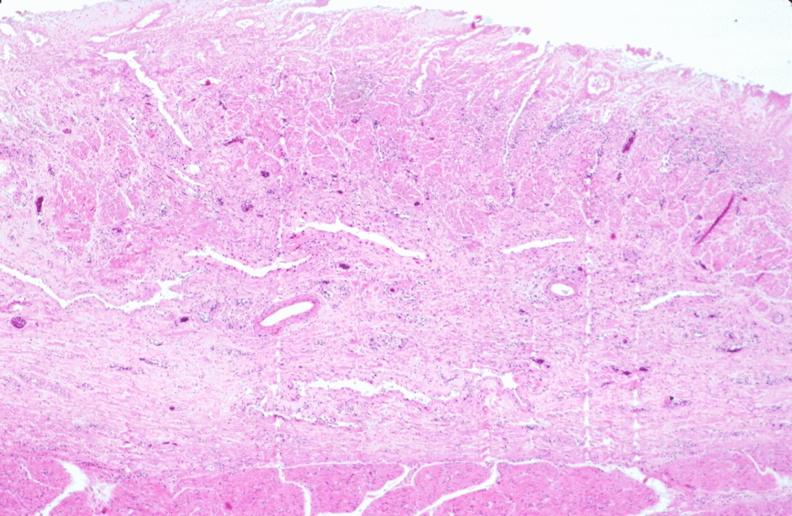does this image show stomach, necrotizing esophagitis and gastritis, sulfuric acid ingested as suicide attempt?
Answer the question using a single word or phrase. Yes 